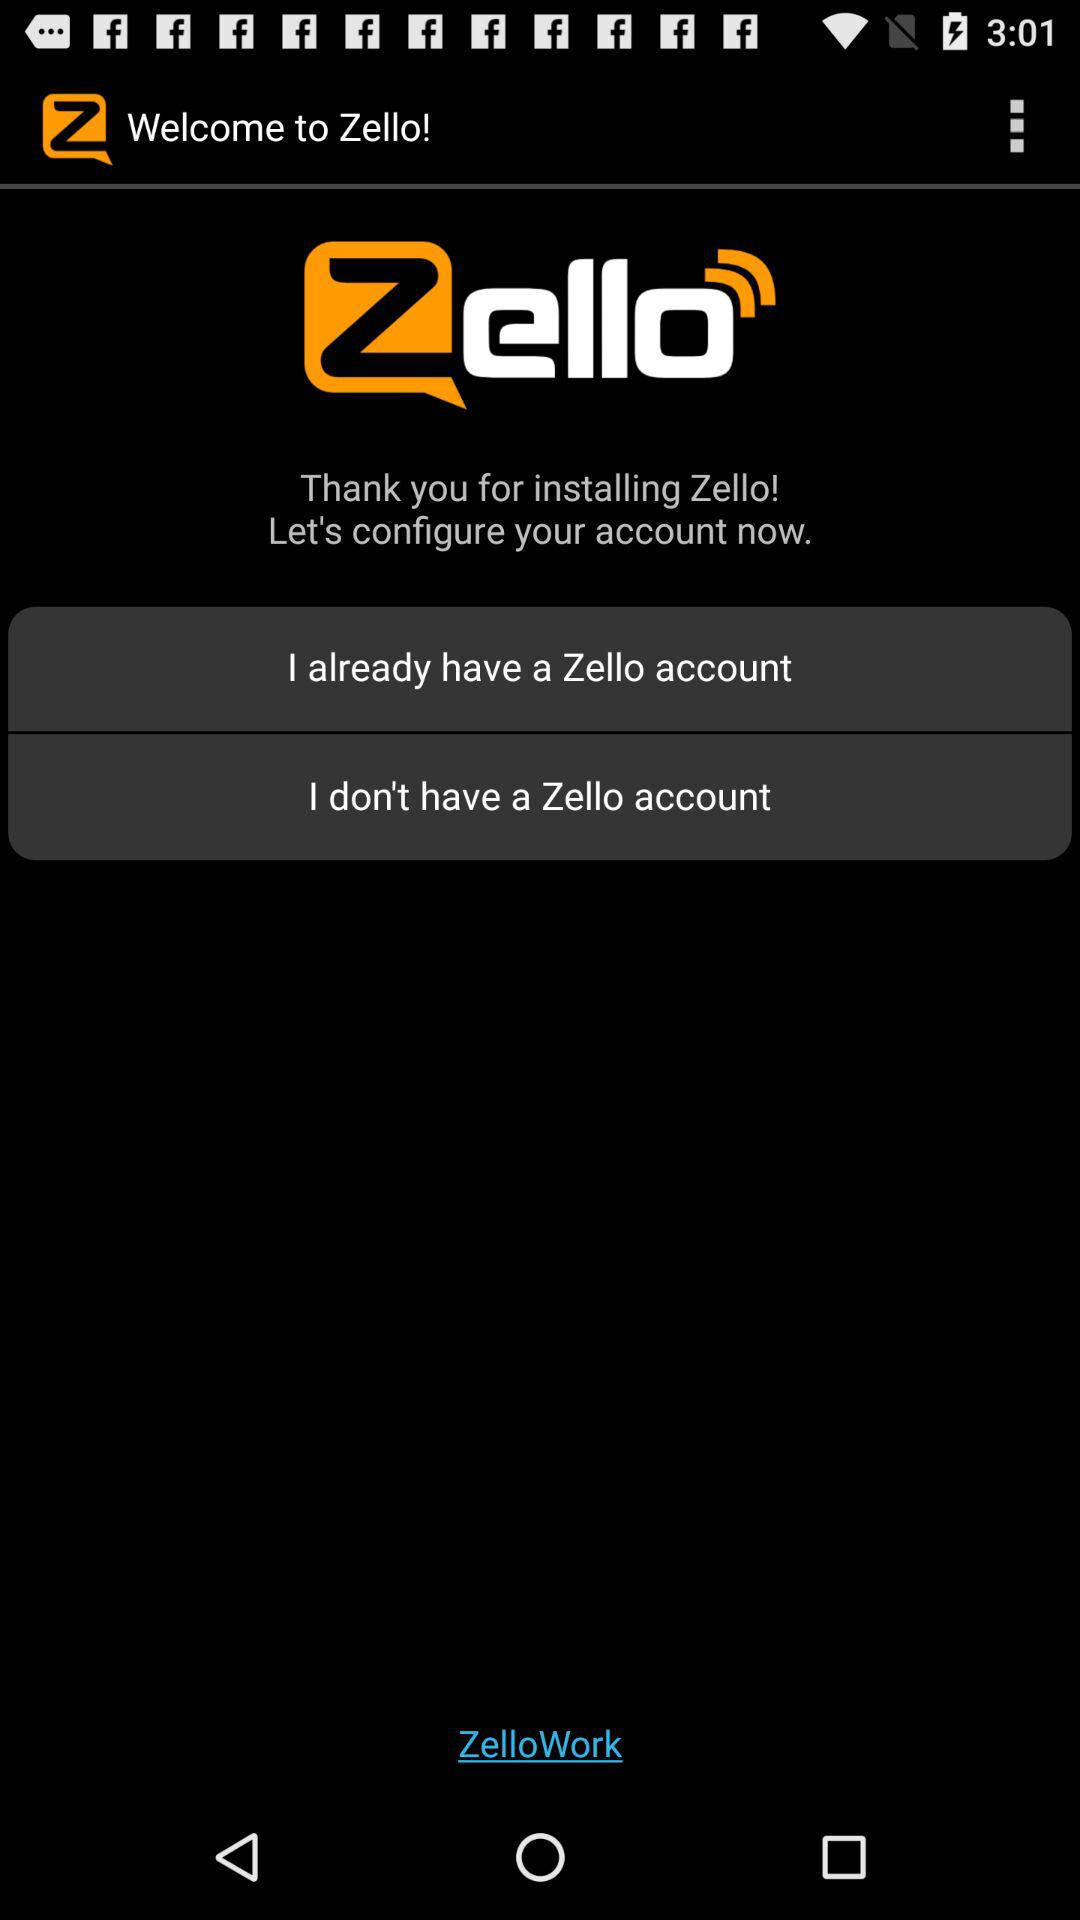What is the name of the application? The name of the application is "Zello". 